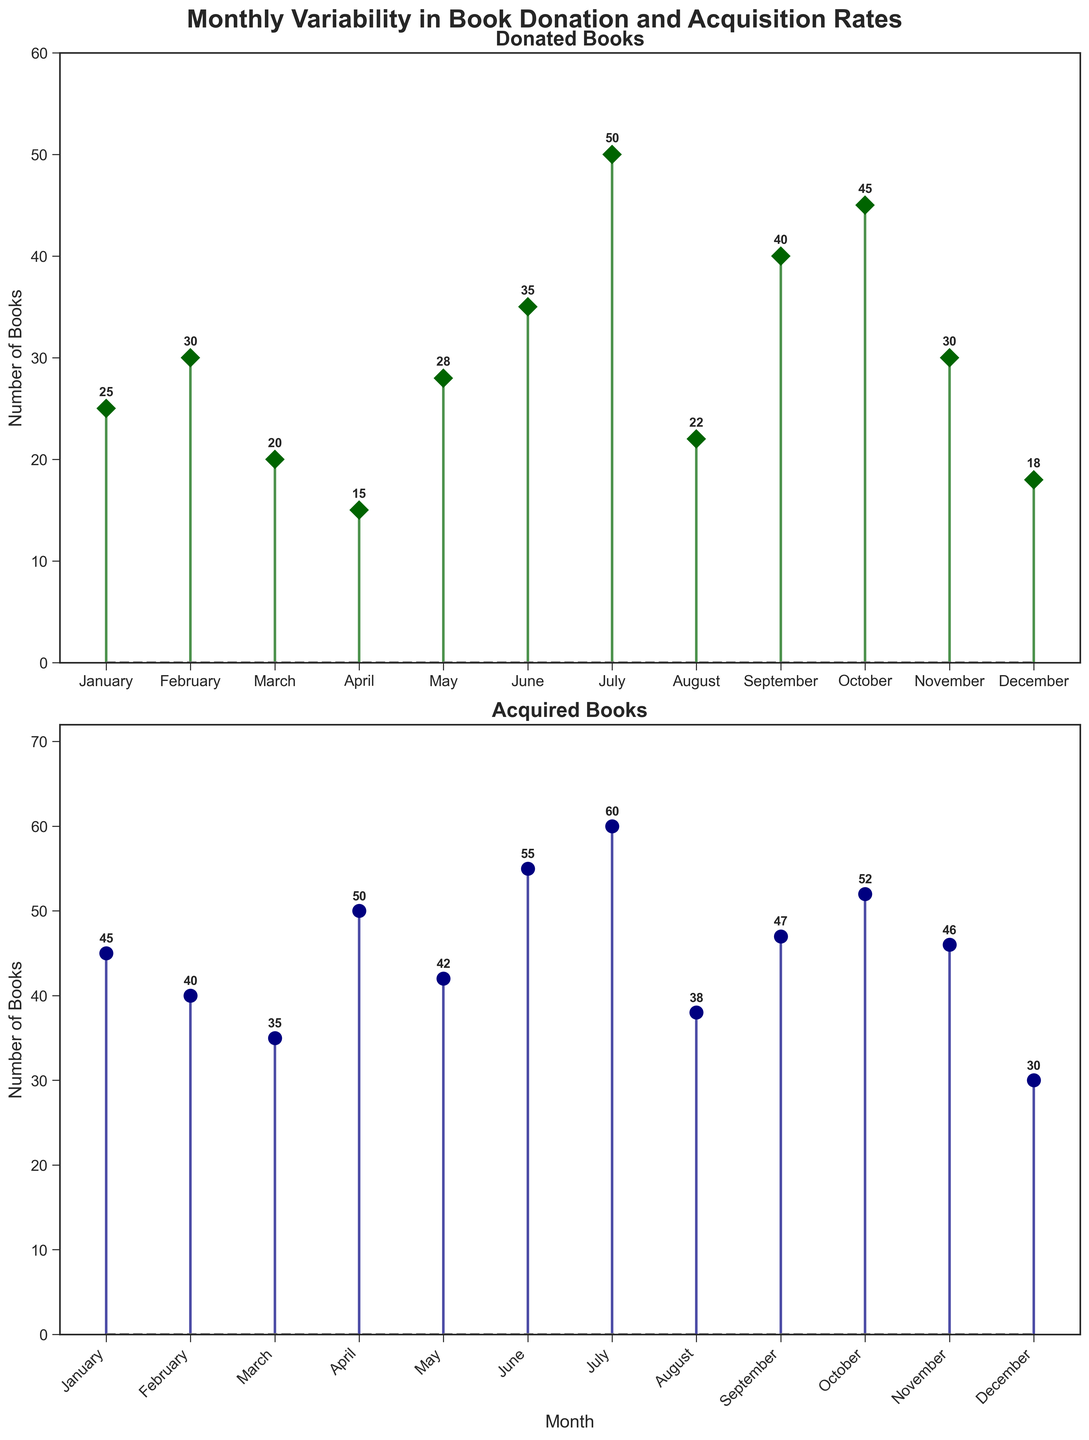What's the title of the top subplot? The title of the top subplot is displayed at the top center of the first plot area. The text reads 'Donated Books'.
Answer: Donated Books Which month had the highest number of donated books? To find the month with the highest number of donated books, look at the vertical extent of the 'Donated Books' stems. July's stem reaches the tallest height at 50 books.
Answer: July How many books were acquired in June? Refer to the second subplot labeled 'Acquired Books'. Locate the June data point, trace the stem upwards to 55 books.
Answer: 55 What's the total number of donated books in the first half of the year? Sum the number of donated books from January to June: 25 (Jan) + 30 (Feb) + 20 (Mar) + 15 (Apr) + 28 (May) + 35 (Jun) = 153 books.
Answer: 153 books Did any month have exactly the same number of donated and acquired books? Compare the 'Donated Books' and 'Acquired Books' for each month. No month has equal donated and acquired books.
Answer: No How many more books were acquired in October compared to acquired in February? Locate the acquired books for both months: October (52) and February (40). Calculate the difference: 52 - 40 = 12.
Answer: 12 books What is the total number of books acquired in the second half of the year? Sum the number of acquired books from July to December: 60 (Jul) + 38 (Aug) + 47 (Sep) + 52 (Oct) + 46 (Nov) + 30 (Dec) = 273 books.
Answer: 273 books Which month had the lowest number of donated books, and how many books were donated that month? Identify the shortest stem in the 'Donated Books' subplot. December has the lowest number of donated books at 18.
Answer: December, 18 How many months had more than 40 books acquired? Count the stems in the 'Acquired Books' subplot exceeding 40 books: January (45), February (40), April (50), May (42), June (55), July (60), September (47), October (52), November (46). There are 8 months.
Answer: 8 months 